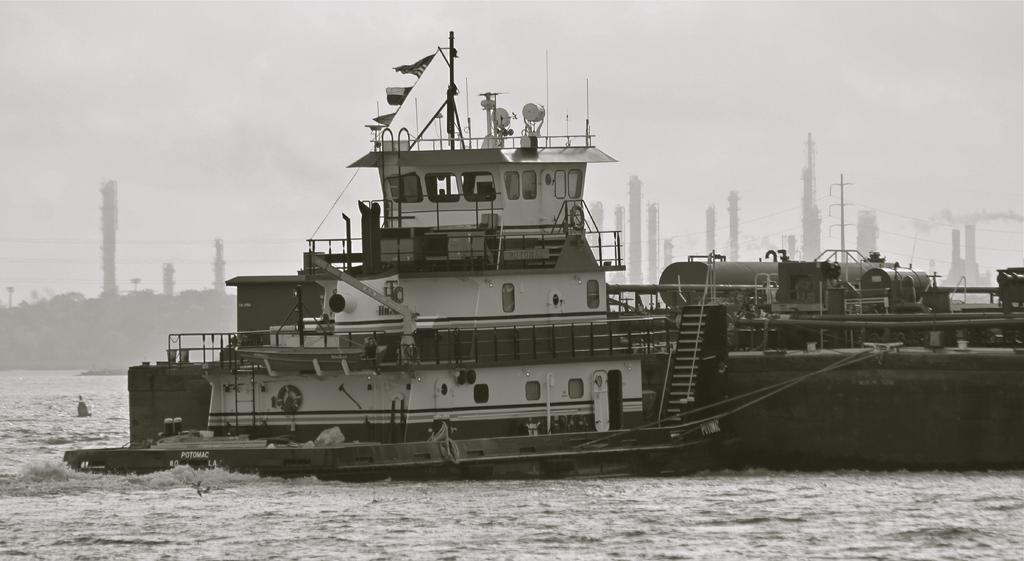What is the color scheme of the image? The image is black and white. What is the main subject in the image? There is a ship in the image. What is the ship doing in the image? The ship is moving in the water. What can be seen in the background of the image? There are towers in the background of the image. What else is present in the image besides the ship? Flags are hanging from a rope in the image. How many flowers are on the ship's deck in the image? There are no flowers present on the ship's deck in the image. What type of lipstick is the ship wearing in the image? The ship is not wearing lipstick, as it is an inanimate object and not capable of wearing makeup. 